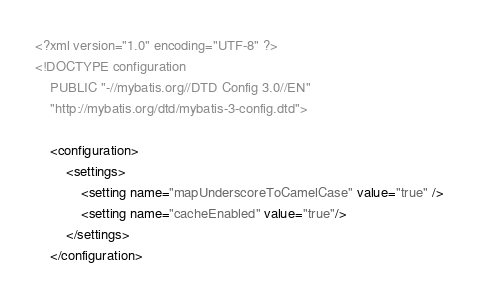<code> <loc_0><loc_0><loc_500><loc_500><_XML_><?xml version="1.0" encoding="UTF-8" ?>
<!DOCTYPE configuration
    PUBLIC "-//mybatis.org//DTD Config 3.0//EN"
    "http://mybatis.org/dtd/mybatis-3-config.dtd">

    <configuration>
        <settings>
            <setting name="mapUnderscoreToCamelCase" value="true" />
            <setting name="cacheEnabled" value="true"/>
        </settings>
    </configuration></code> 